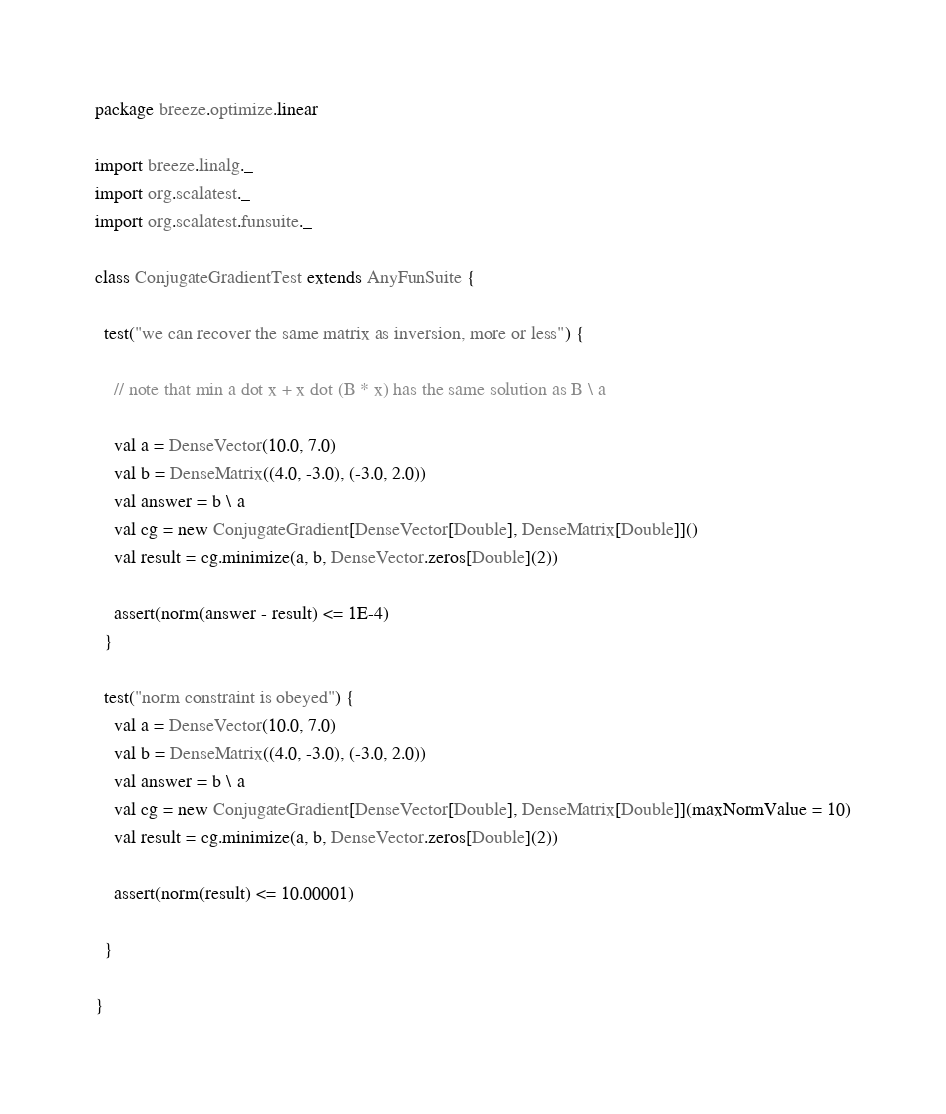<code> <loc_0><loc_0><loc_500><loc_500><_Scala_>package breeze.optimize.linear

import breeze.linalg._
import org.scalatest._
import org.scalatest.funsuite._

class ConjugateGradientTest extends AnyFunSuite {

  test("we can recover the same matrix as inversion, more or less") {

    // note that min a dot x + x dot (B * x) has the same solution as B \ a

    val a = DenseVector(10.0, 7.0)
    val b = DenseMatrix((4.0, -3.0), (-3.0, 2.0))
    val answer = b \ a
    val cg = new ConjugateGradient[DenseVector[Double], DenseMatrix[Double]]()
    val result = cg.minimize(a, b, DenseVector.zeros[Double](2))

    assert(norm(answer - result) <= 1E-4)
  }

  test("norm constraint is obeyed") {
    val a = DenseVector(10.0, 7.0)
    val b = DenseMatrix((4.0, -3.0), (-3.0, 2.0))
    val answer = b \ a
    val cg = new ConjugateGradient[DenseVector[Double], DenseMatrix[Double]](maxNormValue = 10)
    val result = cg.minimize(a, b, DenseVector.zeros[Double](2))

    assert(norm(result) <= 10.00001)

  }

}
</code> 